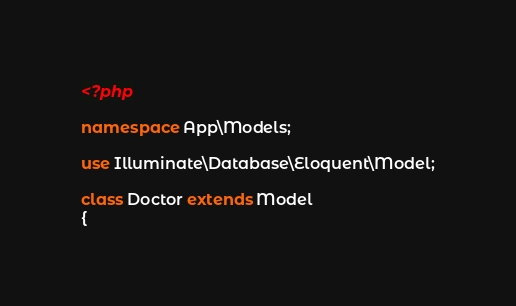Convert code to text. <code><loc_0><loc_0><loc_500><loc_500><_PHP_><?php

namespace App\Models;

use Illuminate\Database\Eloquent\Model;

class Doctor extends Model
{</code> 